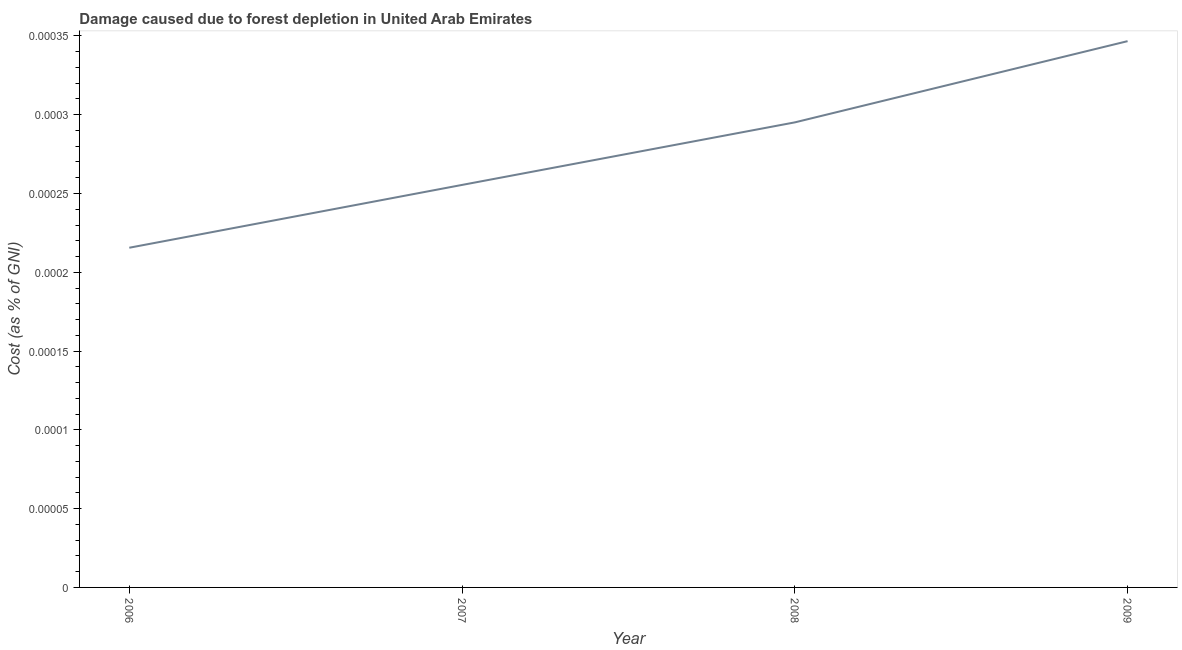What is the damage caused due to forest depletion in 2009?
Provide a succinct answer. 0. Across all years, what is the maximum damage caused due to forest depletion?
Provide a succinct answer. 0. Across all years, what is the minimum damage caused due to forest depletion?
Offer a terse response. 0. What is the sum of the damage caused due to forest depletion?
Offer a very short reply. 0. What is the difference between the damage caused due to forest depletion in 2006 and 2008?
Your response must be concise. -7.955514053303704e-5. What is the average damage caused due to forest depletion per year?
Make the answer very short. 0. What is the median damage caused due to forest depletion?
Give a very brief answer. 0. Do a majority of the years between 2006 and 2008 (inclusive) have damage caused due to forest depletion greater than 0.00023 %?
Provide a short and direct response. Yes. What is the ratio of the damage caused due to forest depletion in 2007 to that in 2009?
Ensure brevity in your answer.  0.74. Is the damage caused due to forest depletion in 2006 less than that in 2007?
Make the answer very short. Yes. What is the difference between the highest and the second highest damage caused due to forest depletion?
Your response must be concise. 5.155105180345399e-5. Is the sum of the damage caused due to forest depletion in 2006 and 2008 greater than the maximum damage caused due to forest depletion across all years?
Your answer should be compact. Yes. What is the difference between the highest and the lowest damage caused due to forest depletion?
Offer a terse response. 0. In how many years, is the damage caused due to forest depletion greater than the average damage caused due to forest depletion taken over all years?
Provide a short and direct response. 2. How many lines are there?
Give a very brief answer. 1. What is the difference between two consecutive major ticks on the Y-axis?
Provide a succinct answer. 5e-5. Are the values on the major ticks of Y-axis written in scientific E-notation?
Your answer should be compact. No. Does the graph contain grids?
Give a very brief answer. No. What is the title of the graph?
Keep it short and to the point. Damage caused due to forest depletion in United Arab Emirates. What is the label or title of the Y-axis?
Provide a succinct answer. Cost (as % of GNI). What is the Cost (as % of GNI) of 2006?
Offer a terse response. 0. What is the Cost (as % of GNI) of 2007?
Provide a succinct answer. 0. What is the Cost (as % of GNI) of 2008?
Provide a succinct answer. 0. What is the Cost (as % of GNI) in 2009?
Ensure brevity in your answer.  0. What is the difference between the Cost (as % of GNI) in 2006 and 2007?
Make the answer very short. -4e-5. What is the difference between the Cost (as % of GNI) in 2006 and 2008?
Your response must be concise. -8e-5. What is the difference between the Cost (as % of GNI) in 2006 and 2009?
Keep it short and to the point. -0. What is the difference between the Cost (as % of GNI) in 2007 and 2008?
Make the answer very short. -4e-5. What is the difference between the Cost (as % of GNI) in 2007 and 2009?
Provide a succinct answer. -9e-5. What is the difference between the Cost (as % of GNI) in 2008 and 2009?
Your answer should be compact. -5e-5. What is the ratio of the Cost (as % of GNI) in 2006 to that in 2007?
Provide a succinct answer. 0.84. What is the ratio of the Cost (as % of GNI) in 2006 to that in 2008?
Your answer should be compact. 0.73. What is the ratio of the Cost (as % of GNI) in 2006 to that in 2009?
Ensure brevity in your answer.  0.62. What is the ratio of the Cost (as % of GNI) in 2007 to that in 2008?
Give a very brief answer. 0.87. What is the ratio of the Cost (as % of GNI) in 2007 to that in 2009?
Give a very brief answer. 0.74. What is the ratio of the Cost (as % of GNI) in 2008 to that in 2009?
Provide a succinct answer. 0.85. 